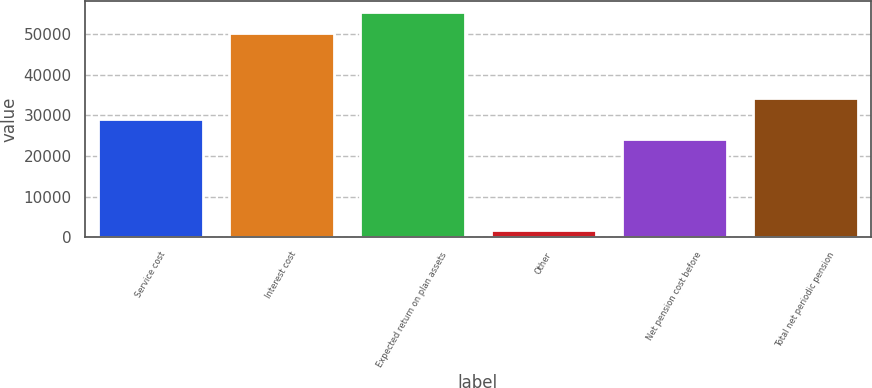<chart> <loc_0><loc_0><loc_500><loc_500><bar_chart><fcel>Service cost<fcel>Interest cost<fcel>Expected return on plan assets<fcel>Other<fcel>Net pension cost before<fcel>Total net periodic pension<nl><fcel>29226.4<fcel>50421<fcel>55527.4<fcel>1820<fcel>24120<fcel>34332.8<nl></chart> 